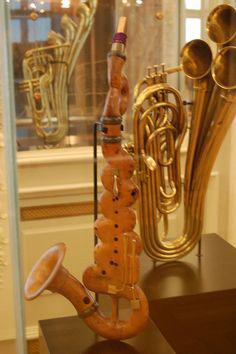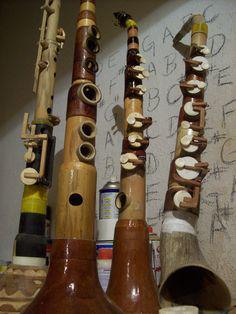The first image is the image on the left, the second image is the image on the right. Given the left and right images, does the statement "One of images contains a saxophone with wood in the background." hold true? Answer yes or no. No. 